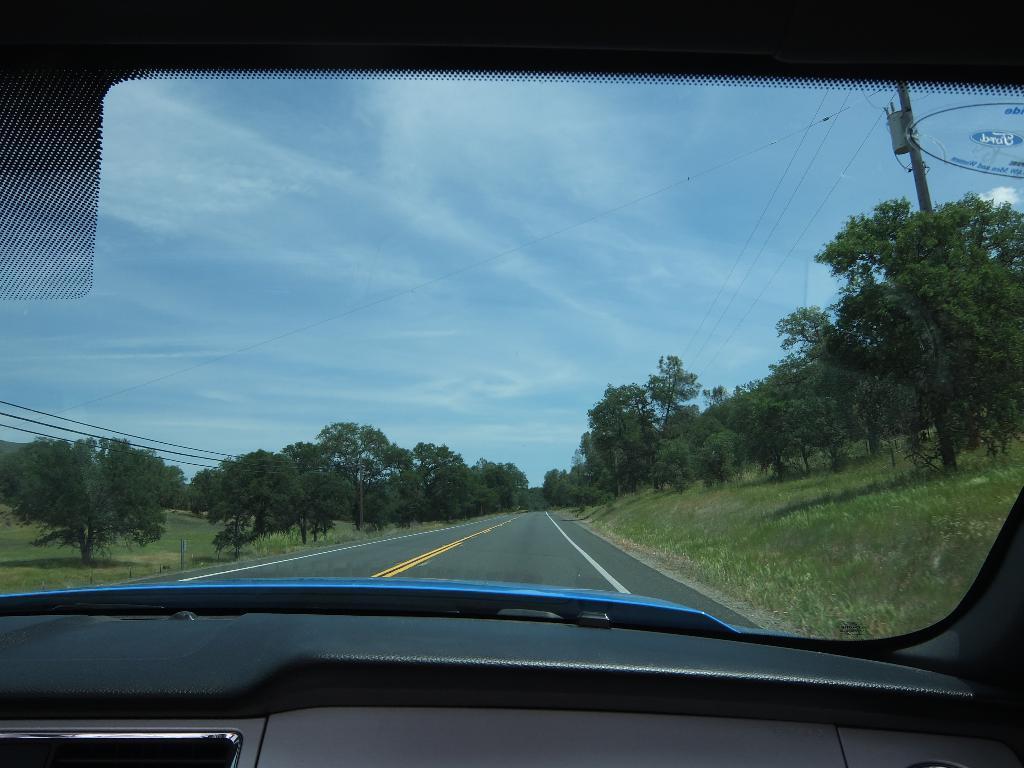How would you summarize this image in a sentence or two? In this image from the dashboard of the car we can see the road, on the either side of the road there are trees, at the top of the image there are electrical cables on the poles. 